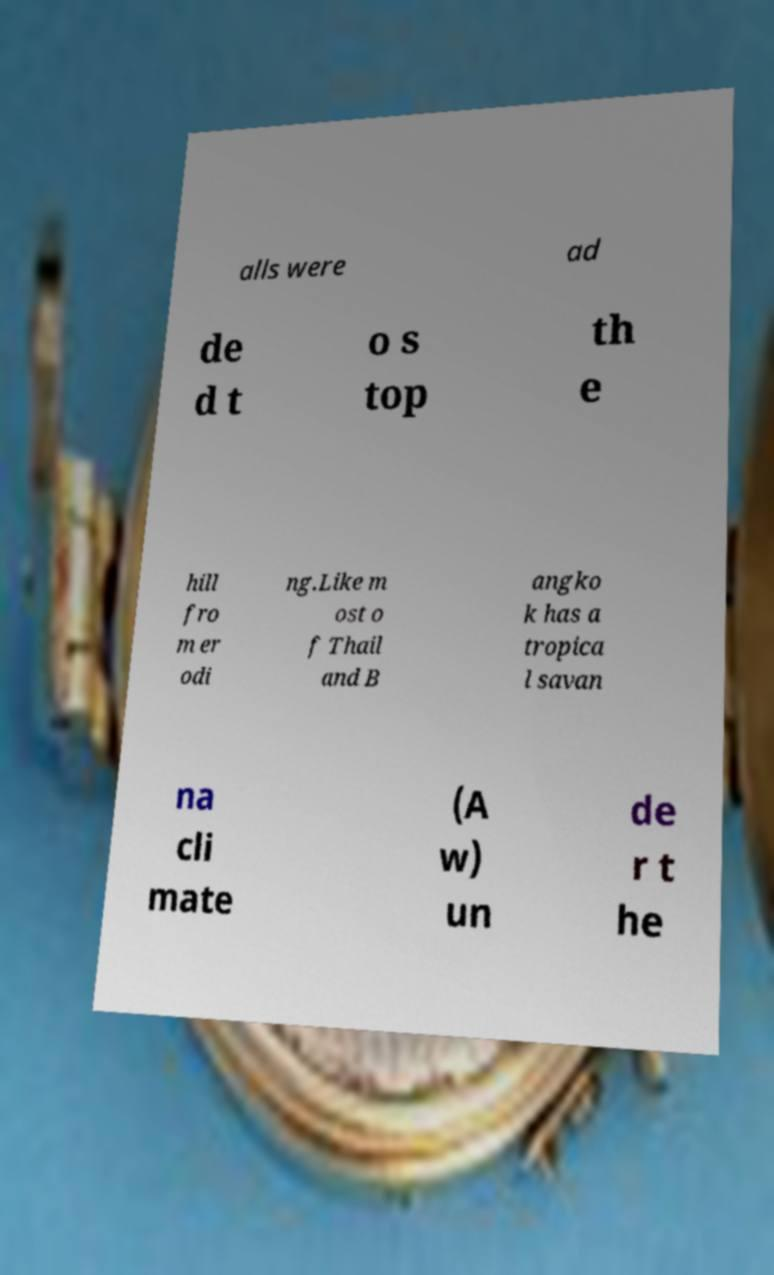Please read and relay the text visible in this image. What does it say? alls were ad de d t o s top th e hill fro m er odi ng.Like m ost o f Thail and B angko k has a tropica l savan na cli mate (A w) un de r t he 